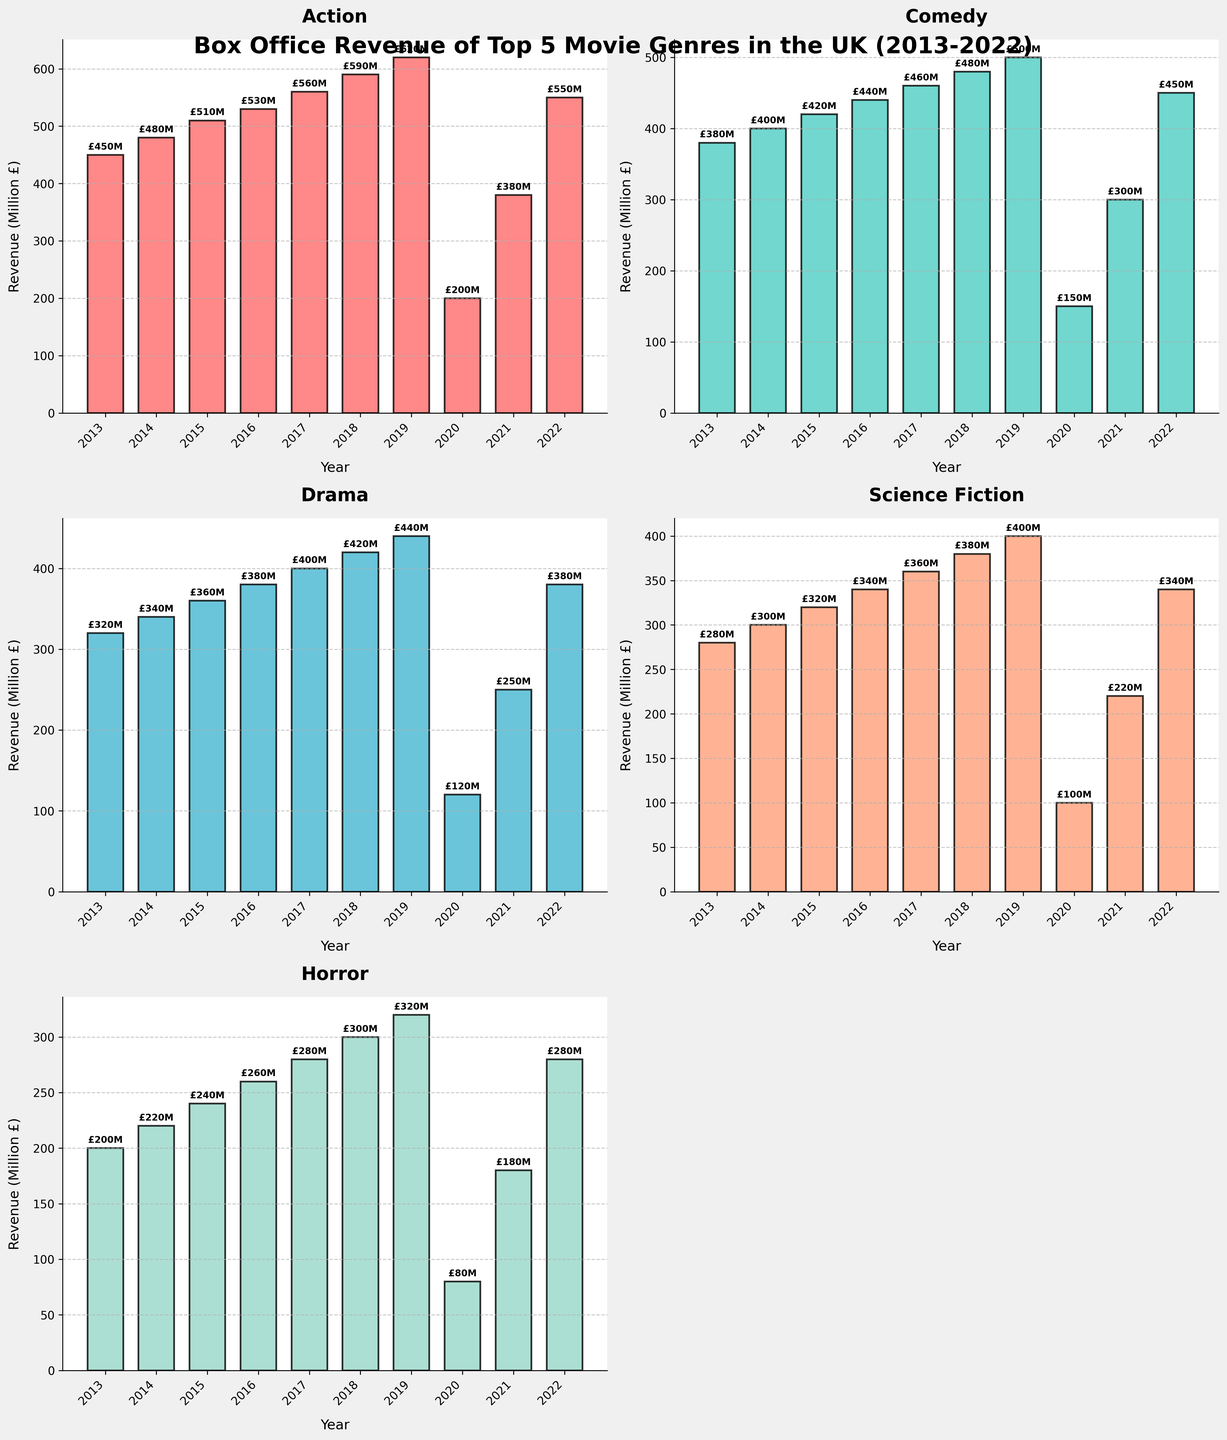How many genres are displayed in the figure? Count the number of individual bar charts, each representing a genre.
Answer: 5 What is the total box office revenue for Action movies in 2018? Look at the bar for Action in 2018 and note its height.
Answer: £590M Which genre experienced the maximum decrease in box office revenue between 2019 and 2020? Calculate the difference for each genre between 2019 and 2020, then identify the genre with the largest drop. Action: 620-200=420, Comedy: 500-150=350, Drama: 440-120=320, Sci-Fi: 400-100=300, Horror: 320-80=240. Action has the maximum decrease.
Answer: Action What's the average box office revenue for Comedy movies over the decade? Sum the revenues for Comedy from 2013 to 2022 and divide by the number of years (10). (380+400+420+440+460+480+500+150+300+450)/10=4380/10
Answer: £438M Did any genre have an increase in revenue from 2021 to 2022? Compare the height of the bars in 2021 and 2022 for each genre. Action: 380-550, Comedy: 300-450, Drama: 250-380, Sci-Fi: 220-340, Horror: 180-280, all show an increase.
Answer: Yes Which genres had their peak box office revenue in the year 2019? Examine the height of the bars for each year and identify the highest one; then find which peaks are in 2019. Action: 620, Comedy: 500, Drama: 440, Sci-Fi: 400, Horror: 320, all peak in 2019.
Answer: All genres What is the difference in box office revenue between Action and Horror films in 2021? Subtract the revenue of Horror from Action in 2021. 380 - 180 = 200
Answer: £200M In which year did Drama movies see the lowest box office revenue? Find the smallest bar for Drama over the years 2013-2022.
Answer: 2020 Which genre had the highest revenue in the year 2022? Compare the bars of each genre in 2022 to see which is the tallest. Action: 550, Comedy: 450, Drama: 380, Sci-Fi: 340, Horror: 280.
Answer: Action How did the revenue change for Science Fiction from 2013 to 2020? Calculate the difference in revenue for Sci-Fi between 2013 and 2020. 280 - 100 = 180
Answer: $180M decrease 